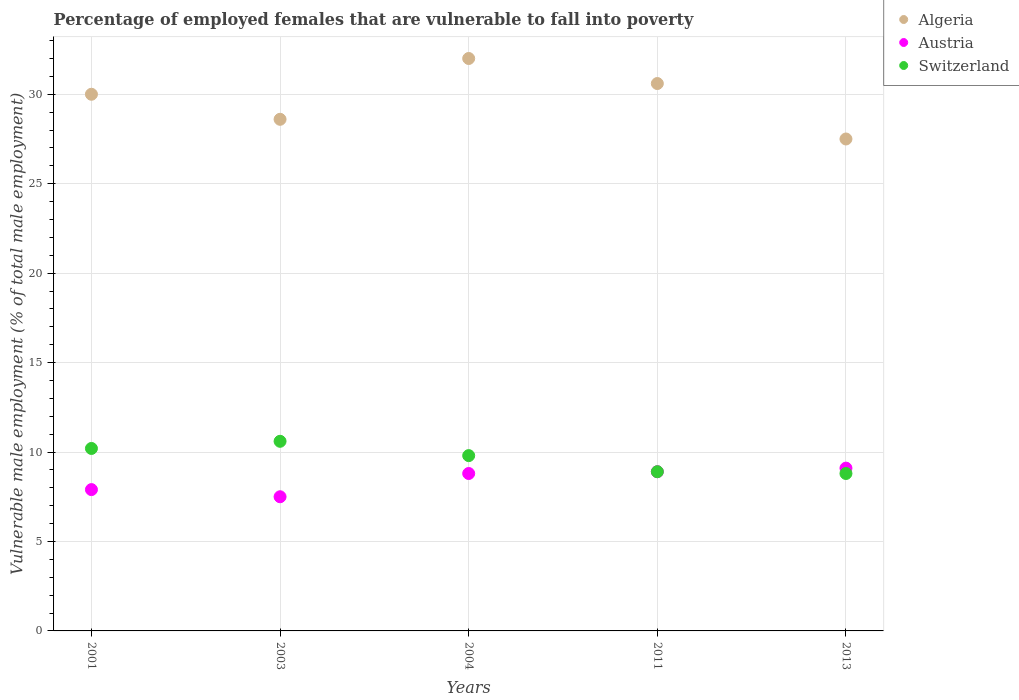How many different coloured dotlines are there?
Keep it short and to the point. 3. What is the percentage of employed females who are vulnerable to fall into poverty in Algeria in 2004?
Offer a very short reply. 32. Across all years, what is the maximum percentage of employed females who are vulnerable to fall into poverty in Austria?
Your answer should be compact. 9.1. In which year was the percentage of employed females who are vulnerable to fall into poverty in Switzerland minimum?
Your answer should be very brief. 2013. What is the total percentage of employed females who are vulnerable to fall into poverty in Austria in the graph?
Keep it short and to the point. 42.2. What is the difference between the percentage of employed females who are vulnerable to fall into poverty in Austria in 2003 and that in 2011?
Your response must be concise. -1.4. What is the difference between the percentage of employed females who are vulnerable to fall into poverty in Switzerland in 2011 and the percentage of employed females who are vulnerable to fall into poverty in Austria in 2001?
Ensure brevity in your answer.  1. What is the average percentage of employed females who are vulnerable to fall into poverty in Algeria per year?
Provide a succinct answer. 29.74. In the year 2004, what is the difference between the percentage of employed females who are vulnerable to fall into poverty in Algeria and percentage of employed females who are vulnerable to fall into poverty in Austria?
Your response must be concise. 23.2. In how many years, is the percentage of employed females who are vulnerable to fall into poverty in Switzerland greater than 25 %?
Your response must be concise. 0. What is the ratio of the percentage of employed females who are vulnerable to fall into poverty in Algeria in 2011 to that in 2013?
Ensure brevity in your answer.  1.11. Is the percentage of employed females who are vulnerable to fall into poverty in Algeria in 2004 less than that in 2013?
Your answer should be compact. No. What is the difference between the highest and the second highest percentage of employed females who are vulnerable to fall into poverty in Switzerland?
Offer a very short reply. 0.4. What is the difference between the highest and the lowest percentage of employed females who are vulnerable to fall into poverty in Austria?
Offer a very short reply. 1.6. In how many years, is the percentage of employed females who are vulnerable to fall into poverty in Algeria greater than the average percentage of employed females who are vulnerable to fall into poverty in Algeria taken over all years?
Keep it short and to the point. 3. Is the sum of the percentage of employed females who are vulnerable to fall into poverty in Austria in 2003 and 2011 greater than the maximum percentage of employed females who are vulnerable to fall into poverty in Switzerland across all years?
Provide a short and direct response. Yes. Is the percentage of employed females who are vulnerable to fall into poverty in Algeria strictly greater than the percentage of employed females who are vulnerable to fall into poverty in Austria over the years?
Offer a very short reply. Yes. Is the percentage of employed females who are vulnerable to fall into poverty in Switzerland strictly less than the percentage of employed females who are vulnerable to fall into poverty in Algeria over the years?
Your response must be concise. Yes. How many years are there in the graph?
Provide a short and direct response. 5. What is the difference between two consecutive major ticks on the Y-axis?
Give a very brief answer. 5. Does the graph contain grids?
Make the answer very short. Yes. Where does the legend appear in the graph?
Provide a succinct answer. Top right. How are the legend labels stacked?
Keep it short and to the point. Vertical. What is the title of the graph?
Your response must be concise. Percentage of employed females that are vulnerable to fall into poverty. What is the label or title of the X-axis?
Keep it short and to the point. Years. What is the label or title of the Y-axis?
Make the answer very short. Vulnerable male employment (% of total male employment). What is the Vulnerable male employment (% of total male employment) of Austria in 2001?
Your answer should be compact. 7.9. What is the Vulnerable male employment (% of total male employment) in Switzerland in 2001?
Offer a terse response. 10.2. What is the Vulnerable male employment (% of total male employment) of Algeria in 2003?
Offer a very short reply. 28.6. What is the Vulnerable male employment (% of total male employment) of Austria in 2003?
Offer a terse response. 7.5. What is the Vulnerable male employment (% of total male employment) of Switzerland in 2003?
Make the answer very short. 10.6. What is the Vulnerable male employment (% of total male employment) of Algeria in 2004?
Your response must be concise. 32. What is the Vulnerable male employment (% of total male employment) of Austria in 2004?
Give a very brief answer. 8.8. What is the Vulnerable male employment (% of total male employment) in Switzerland in 2004?
Offer a terse response. 9.8. What is the Vulnerable male employment (% of total male employment) of Algeria in 2011?
Offer a terse response. 30.6. What is the Vulnerable male employment (% of total male employment) of Austria in 2011?
Offer a terse response. 8.9. What is the Vulnerable male employment (% of total male employment) in Switzerland in 2011?
Your answer should be very brief. 8.9. What is the Vulnerable male employment (% of total male employment) in Austria in 2013?
Ensure brevity in your answer.  9.1. What is the Vulnerable male employment (% of total male employment) in Switzerland in 2013?
Offer a very short reply. 8.8. Across all years, what is the maximum Vulnerable male employment (% of total male employment) in Algeria?
Your answer should be very brief. 32. Across all years, what is the maximum Vulnerable male employment (% of total male employment) in Austria?
Offer a terse response. 9.1. Across all years, what is the maximum Vulnerable male employment (% of total male employment) in Switzerland?
Keep it short and to the point. 10.6. Across all years, what is the minimum Vulnerable male employment (% of total male employment) of Austria?
Your response must be concise. 7.5. Across all years, what is the minimum Vulnerable male employment (% of total male employment) of Switzerland?
Provide a short and direct response. 8.8. What is the total Vulnerable male employment (% of total male employment) of Algeria in the graph?
Ensure brevity in your answer.  148.7. What is the total Vulnerable male employment (% of total male employment) in Austria in the graph?
Offer a terse response. 42.2. What is the total Vulnerable male employment (% of total male employment) of Switzerland in the graph?
Provide a short and direct response. 48.3. What is the difference between the Vulnerable male employment (% of total male employment) of Algeria in 2001 and that in 2003?
Keep it short and to the point. 1.4. What is the difference between the Vulnerable male employment (% of total male employment) in Austria in 2001 and that in 2003?
Give a very brief answer. 0.4. What is the difference between the Vulnerable male employment (% of total male employment) in Switzerland in 2001 and that in 2003?
Your answer should be compact. -0.4. What is the difference between the Vulnerable male employment (% of total male employment) of Algeria in 2001 and that in 2004?
Keep it short and to the point. -2. What is the difference between the Vulnerable male employment (% of total male employment) of Switzerland in 2001 and that in 2004?
Offer a very short reply. 0.4. What is the difference between the Vulnerable male employment (% of total male employment) in Algeria in 2001 and that in 2011?
Keep it short and to the point. -0.6. What is the difference between the Vulnerable male employment (% of total male employment) of Switzerland in 2001 and that in 2013?
Ensure brevity in your answer.  1.4. What is the difference between the Vulnerable male employment (% of total male employment) of Switzerland in 2003 and that in 2004?
Make the answer very short. 0.8. What is the difference between the Vulnerable male employment (% of total male employment) of Switzerland in 2003 and that in 2013?
Your answer should be compact. 1.8. What is the difference between the Vulnerable male employment (% of total male employment) in Algeria in 2004 and that in 2011?
Offer a very short reply. 1.4. What is the difference between the Vulnerable male employment (% of total male employment) in Austria in 2004 and that in 2011?
Keep it short and to the point. -0.1. What is the difference between the Vulnerable male employment (% of total male employment) in Switzerland in 2004 and that in 2011?
Ensure brevity in your answer.  0.9. What is the difference between the Vulnerable male employment (% of total male employment) in Algeria in 2001 and the Vulnerable male employment (% of total male employment) in Austria in 2003?
Offer a terse response. 22.5. What is the difference between the Vulnerable male employment (% of total male employment) in Algeria in 2001 and the Vulnerable male employment (% of total male employment) in Switzerland in 2003?
Keep it short and to the point. 19.4. What is the difference between the Vulnerable male employment (% of total male employment) in Algeria in 2001 and the Vulnerable male employment (% of total male employment) in Austria in 2004?
Ensure brevity in your answer.  21.2. What is the difference between the Vulnerable male employment (% of total male employment) of Algeria in 2001 and the Vulnerable male employment (% of total male employment) of Switzerland in 2004?
Provide a short and direct response. 20.2. What is the difference between the Vulnerable male employment (% of total male employment) in Austria in 2001 and the Vulnerable male employment (% of total male employment) in Switzerland in 2004?
Keep it short and to the point. -1.9. What is the difference between the Vulnerable male employment (% of total male employment) in Algeria in 2001 and the Vulnerable male employment (% of total male employment) in Austria in 2011?
Keep it short and to the point. 21.1. What is the difference between the Vulnerable male employment (% of total male employment) of Algeria in 2001 and the Vulnerable male employment (% of total male employment) of Switzerland in 2011?
Provide a short and direct response. 21.1. What is the difference between the Vulnerable male employment (% of total male employment) in Algeria in 2001 and the Vulnerable male employment (% of total male employment) in Austria in 2013?
Your answer should be very brief. 20.9. What is the difference between the Vulnerable male employment (% of total male employment) in Algeria in 2001 and the Vulnerable male employment (% of total male employment) in Switzerland in 2013?
Offer a very short reply. 21.2. What is the difference between the Vulnerable male employment (% of total male employment) in Austria in 2001 and the Vulnerable male employment (% of total male employment) in Switzerland in 2013?
Offer a very short reply. -0.9. What is the difference between the Vulnerable male employment (% of total male employment) in Algeria in 2003 and the Vulnerable male employment (% of total male employment) in Austria in 2004?
Make the answer very short. 19.8. What is the difference between the Vulnerable male employment (% of total male employment) of Austria in 2003 and the Vulnerable male employment (% of total male employment) of Switzerland in 2004?
Give a very brief answer. -2.3. What is the difference between the Vulnerable male employment (% of total male employment) of Algeria in 2003 and the Vulnerable male employment (% of total male employment) of Austria in 2011?
Give a very brief answer. 19.7. What is the difference between the Vulnerable male employment (% of total male employment) of Algeria in 2003 and the Vulnerable male employment (% of total male employment) of Switzerland in 2011?
Your answer should be compact. 19.7. What is the difference between the Vulnerable male employment (% of total male employment) of Algeria in 2003 and the Vulnerable male employment (% of total male employment) of Austria in 2013?
Your answer should be compact. 19.5. What is the difference between the Vulnerable male employment (% of total male employment) in Algeria in 2003 and the Vulnerable male employment (% of total male employment) in Switzerland in 2013?
Your answer should be compact. 19.8. What is the difference between the Vulnerable male employment (% of total male employment) of Algeria in 2004 and the Vulnerable male employment (% of total male employment) of Austria in 2011?
Make the answer very short. 23.1. What is the difference between the Vulnerable male employment (% of total male employment) in Algeria in 2004 and the Vulnerable male employment (% of total male employment) in Switzerland in 2011?
Ensure brevity in your answer.  23.1. What is the difference between the Vulnerable male employment (% of total male employment) in Austria in 2004 and the Vulnerable male employment (% of total male employment) in Switzerland in 2011?
Your answer should be compact. -0.1. What is the difference between the Vulnerable male employment (% of total male employment) in Algeria in 2004 and the Vulnerable male employment (% of total male employment) in Austria in 2013?
Make the answer very short. 22.9. What is the difference between the Vulnerable male employment (% of total male employment) in Algeria in 2004 and the Vulnerable male employment (% of total male employment) in Switzerland in 2013?
Your answer should be very brief. 23.2. What is the difference between the Vulnerable male employment (% of total male employment) of Algeria in 2011 and the Vulnerable male employment (% of total male employment) of Switzerland in 2013?
Keep it short and to the point. 21.8. What is the average Vulnerable male employment (% of total male employment) in Algeria per year?
Ensure brevity in your answer.  29.74. What is the average Vulnerable male employment (% of total male employment) in Austria per year?
Offer a very short reply. 8.44. What is the average Vulnerable male employment (% of total male employment) of Switzerland per year?
Your answer should be very brief. 9.66. In the year 2001, what is the difference between the Vulnerable male employment (% of total male employment) in Algeria and Vulnerable male employment (% of total male employment) in Austria?
Provide a short and direct response. 22.1. In the year 2001, what is the difference between the Vulnerable male employment (% of total male employment) of Algeria and Vulnerable male employment (% of total male employment) of Switzerland?
Ensure brevity in your answer.  19.8. In the year 2001, what is the difference between the Vulnerable male employment (% of total male employment) in Austria and Vulnerable male employment (% of total male employment) in Switzerland?
Give a very brief answer. -2.3. In the year 2003, what is the difference between the Vulnerable male employment (% of total male employment) of Algeria and Vulnerable male employment (% of total male employment) of Austria?
Your answer should be compact. 21.1. In the year 2003, what is the difference between the Vulnerable male employment (% of total male employment) of Algeria and Vulnerable male employment (% of total male employment) of Switzerland?
Give a very brief answer. 18. In the year 2004, what is the difference between the Vulnerable male employment (% of total male employment) in Algeria and Vulnerable male employment (% of total male employment) in Austria?
Provide a succinct answer. 23.2. In the year 2011, what is the difference between the Vulnerable male employment (% of total male employment) in Algeria and Vulnerable male employment (% of total male employment) in Austria?
Provide a short and direct response. 21.7. In the year 2011, what is the difference between the Vulnerable male employment (% of total male employment) of Algeria and Vulnerable male employment (% of total male employment) of Switzerland?
Keep it short and to the point. 21.7. In the year 2011, what is the difference between the Vulnerable male employment (% of total male employment) of Austria and Vulnerable male employment (% of total male employment) of Switzerland?
Your answer should be very brief. 0. In the year 2013, what is the difference between the Vulnerable male employment (% of total male employment) in Algeria and Vulnerable male employment (% of total male employment) in Austria?
Provide a short and direct response. 18.4. What is the ratio of the Vulnerable male employment (% of total male employment) in Algeria in 2001 to that in 2003?
Ensure brevity in your answer.  1.05. What is the ratio of the Vulnerable male employment (% of total male employment) of Austria in 2001 to that in 2003?
Make the answer very short. 1.05. What is the ratio of the Vulnerable male employment (% of total male employment) in Switzerland in 2001 to that in 2003?
Ensure brevity in your answer.  0.96. What is the ratio of the Vulnerable male employment (% of total male employment) in Austria in 2001 to that in 2004?
Provide a succinct answer. 0.9. What is the ratio of the Vulnerable male employment (% of total male employment) of Switzerland in 2001 to that in 2004?
Offer a terse response. 1.04. What is the ratio of the Vulnerable male employment (% of total male employment) in Algeria in 2001 to that in 2011?
Keep it short and to the point. 0.98. What is the ratio of the Vulnerable male employment (% of total male employment) of Austria in 2001 to that in 2011?
Provide a short and direct response. 0.89. What is the ratio of the Vulnerable male employment (% of total male employment) in Switzerland in 2001 to that in 2011?
Your answer should be compact. 1.15. What is the ratio of the Vulnerable male employment (% of total male employment) in Algeria in 2001 to that in 2013?
Give a very brief answer. 1.09. What is the ratio of the Vulnerable male employment (% of total male employment) of Austria in 2001 to that in 2013?
Provide a short and direct response. 0.87. What is the ratio of the Vulnerable male employment (% of total male employment) of Switzerland in 2001 to that in 2013?
Provide a short and direct response. 1.16. What is the ratio of the Vulnerable male employment (% of total male employment) in Algeria in 2003 to that in 2004?
Keep it short and to the point. 0.89. What is the ratio of the Vulnerable male employment (% of total male employment) in Austria in 2003 to that in 2004?
Ensure brevity in your answer.  0.85. What is the ratio of the Vulnerable male employment (% of total male employment) of Switzerland in 2003 to that in 2004?
Offer a terse response. 1.08. What is the ratio of the Vulnerable male employment (% of total male employment) in Algeria in 2003 to that in 2011?
Provide a short and direct response. 0.93. What is the ratio of the Vulnerable male employment (% of total male employment) of Austria in 2003 to that in 2011?
Offer a very short reply. 0.84. What is the ratio of the Vulnerable male employment (% of total male employment) of Switzerland in 2003 to that in 2011?
Make the answer very short. 1.19. What is the ratio of the Vulnerable male employment (% of total male employment) in Austria in 2003 to that in 2013?
Make the answer very short. 0.82. What is the ratio of the Vulnerable male employment (% of total male employment) of Switzerland in 2003 to that in 2013?
Ensure brevity in your answer.  1.2. What is the ratio of the Vulnerable male employment (% of total male employment) in Algeria in 2004 to that in 2011?
Provide a short and direct response. 1.05. What is the ratio of the Vulnerable male employment (% of total male employment) in Switzerland in 2004 to that in 2011?
Offer a very short reply. 1.1. What is the ratio of the Vulnerable male employment (% of total male employment) in Algeria in 2004 to that in 2013?
Ensure brevity in your answer.  1.16. What is the ratio of the Vulnerable male employment (% of total male employment) of Austria in 2004 to that in 2013?
Your answer should be compact. 0.97. What is the ratio of the Vulnerable male employment (% of total male employment) in Switzerland in 2004 to that in 2013?
Keep it short and to the point. 1.11. What is the ratio of the Vulnerable male employment (% of total male employment) in Algeria in 2011 to that in 2013?
Ensure brevity in your answer.  1.11. What is the ratio of the Vulnerable male employment (% of total male employment) of Switzerland in 2011 to that in 2013?
Your answer should be very brief. 1.01. What is the difference between the highest and the second highest Vulnerable male employment (% of total male employment) of Algeria?
Give a very brief answer. 1.4. What is the difference between the highest and the second highest Vulnerable male employment (% of total male employment) of Switzerland?
Provide a succinct answer. 0.4. What is the difference between the highest and the lowest Vulnerable male employment (% of total male employment) in Algeria?
Your response must be concise. 4.5. What is the difference between the highest and the lowest Vulnerable male employment (% of total male employment) of Austria?
Your response must be concise. 1.6. 